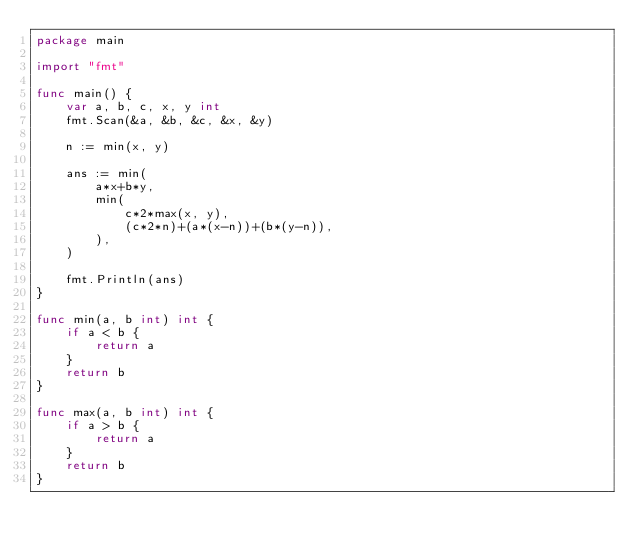<code> <loc_0><loc_0><loc_500><loc_500><_Go_>package main

import "fmt"

func main() {
	var a, b, c, x, y int
	fmt.Scan(&a, &b, &c, &x, &y)

	n := min(x, y)

	ans := min(
		a*x+b*y,
		min(
			c*2*max(x, y),
			(c*2*n)+(a*(x-n))+(b*(y-n)),
		),
	)

	fmt.Println(ans)
}

func min(a, b int) int {
	if a < b {
		return a
	}
	return b
}

func max(a, b int) int {
	if a > b {
		return a
	}
	return b
}
</code> 